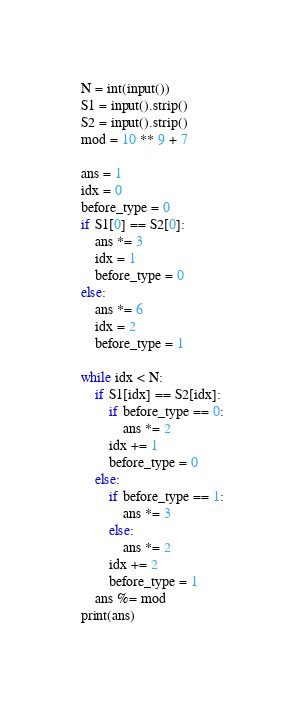<code> <loc_0><loc_0><loc_500><loc_500><_Python_>N = int(input())
S1 = input().strip()
S2 = input().strip()
mod = 10 ** 9 + 7

ans = 1
idx = 0
before_type = 0
if S1[0] == S2[0]:
    ans *= 3
    idx = 1
    before_type = 0
else:
    ans *= 6
    idx = 2
    before_type = 1

while idx < N:
    if S1[idx] == S2[idx]:
        if before_type == 0:
            ans *= 2
        idx += 1
        before_type = 0
    else:
        if before_type == 1:
            ans *= 3
        else:
            ans *= 2
        idx += 2
        before_type = 1
    ans %= mod
print(ans)</code> 